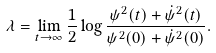<formula> <loc_0><loc_0><loc_500><loc_500>\lambda = \lim _ { t \to \infty } \frac { 1 } { 2 } \log \frac { \psi ^ { 2 } ( t ) + \dot { \psi } ^ { 2 } ( t ) } { \psi ^ { 2 } ( 0 ) + \dot { \psi } ^ { 2 } ( 0 ) } .</formula> 